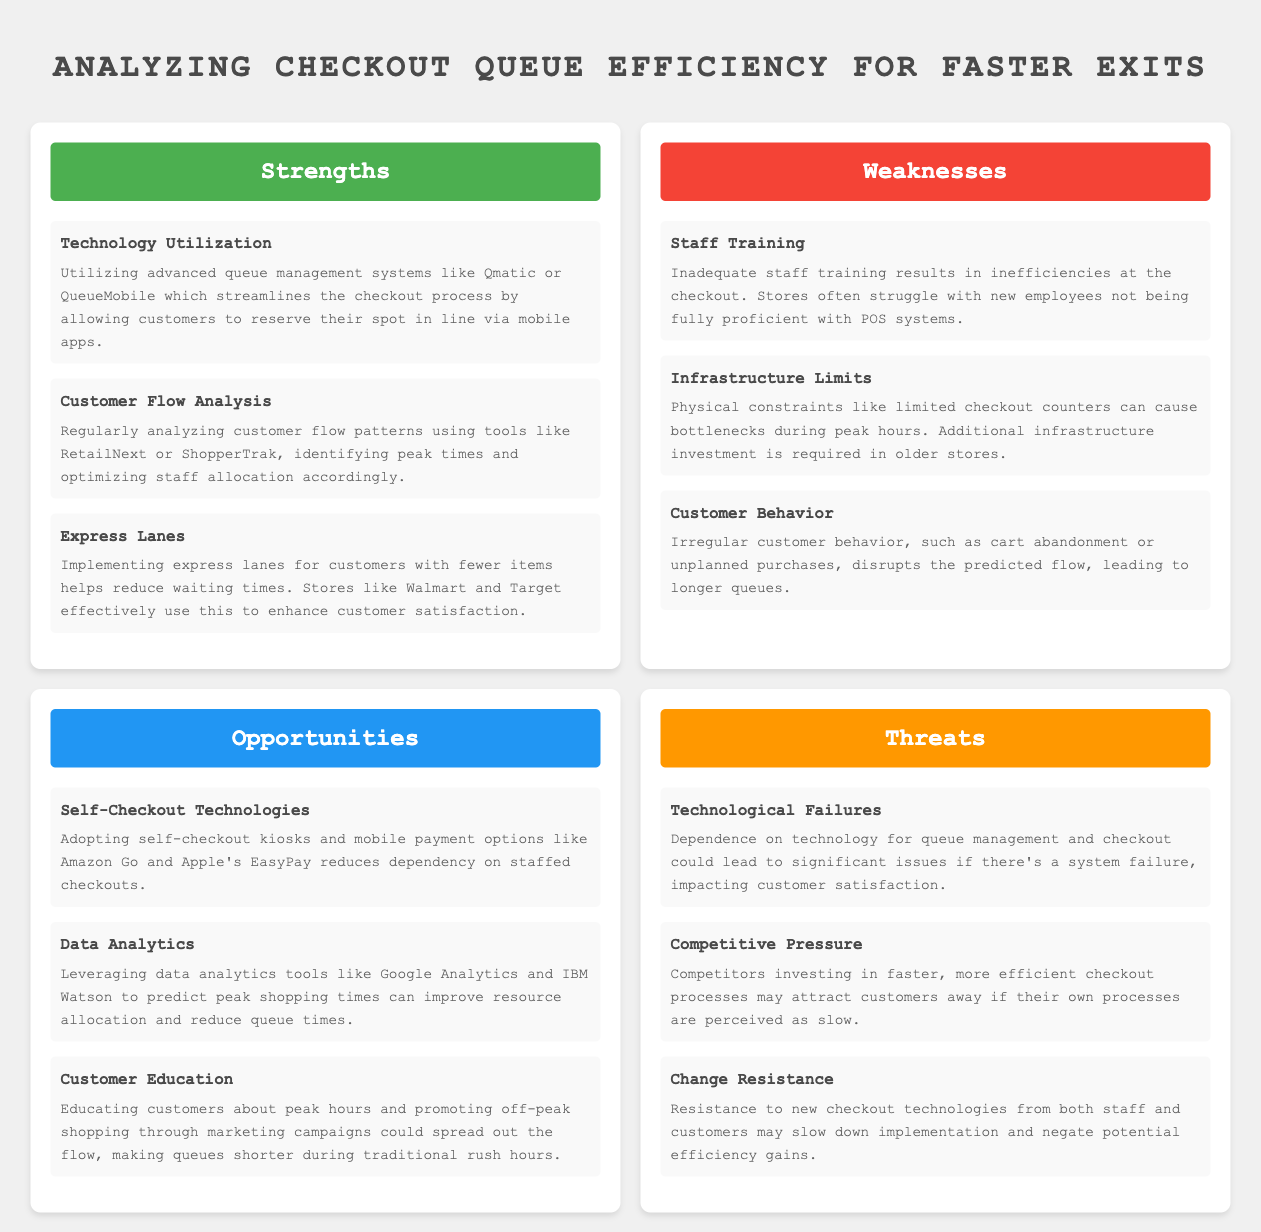What is the title of the document? The title is stated prominently at the beginning of the document, which is "Analyzing Checkout Queue Efficiency for Faster Exits."
Answer: Analyzing Checkout Queue Efficiency for Faster Exits How many strengths are listed? The document contains a specific section titled "Strengths," where three strengths are outlined.
Answer: 3 What technology is mentioned as being utilized for queue management? The document lists specific technologies that are part of the strengths, such as Qmatic or QueueMobile.
Answer: Qmatic or QueueMobile Which opportunity involves using kiosks? The opportunity section mentions self-checkout technologies that include kiosks as a way to reduce dependence on staffed checkouts.
Answer: Self-Checkout Technologies What major threat relates to customer behavior? The mention of customer behavior and its impact on the checkout process is classified under "Change Resistance" in the threats section.
Answer: Change Resistance What is one consequence of technological failures? The document specifies that dependence on technology could lead to significant issues affecting customer satisfaction if there is a system failure.
Answer: customer satisfaction How does the document suggest educating customers? It indicates that educating customers about peak hours could help spread out the flow, as detailed in the opportunities section.
Answer: Educating customers What specific tool is mentioned for analyzing customer flow patterns? The document refers to particular tools such as RetailNext or ShopperTrak as methods for analyzing customer flow.
Answer: RetailNext or ShopperTrak What is one issue caused by inadequate staff training? The weaknesses section states that inadequate staff training leads to inefficiencies at the checkout process.
Answer: Inefficiencies at the checkout 